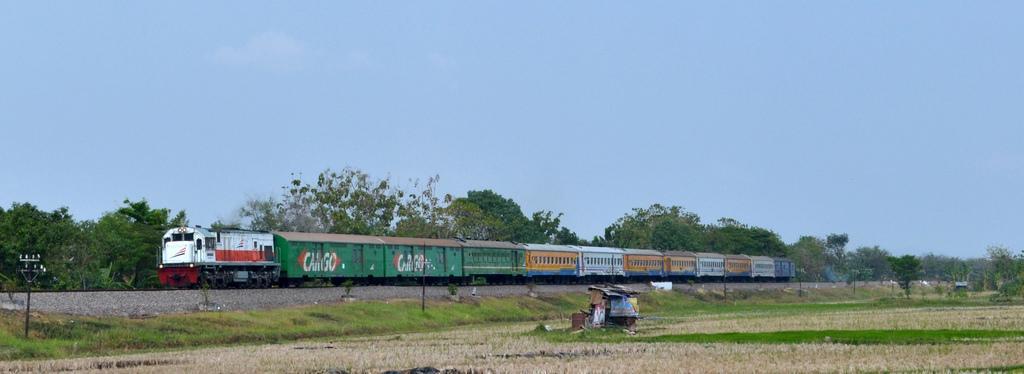Please provide a concise description of this image. At the bottom of the image there is grass on the ground. In the middle of the ground there is a hut with roofs and some other objects. There are electrical poles with wires. And also there is a train on the train track. Behind the train there are trees. At the top of the image there is sky. 